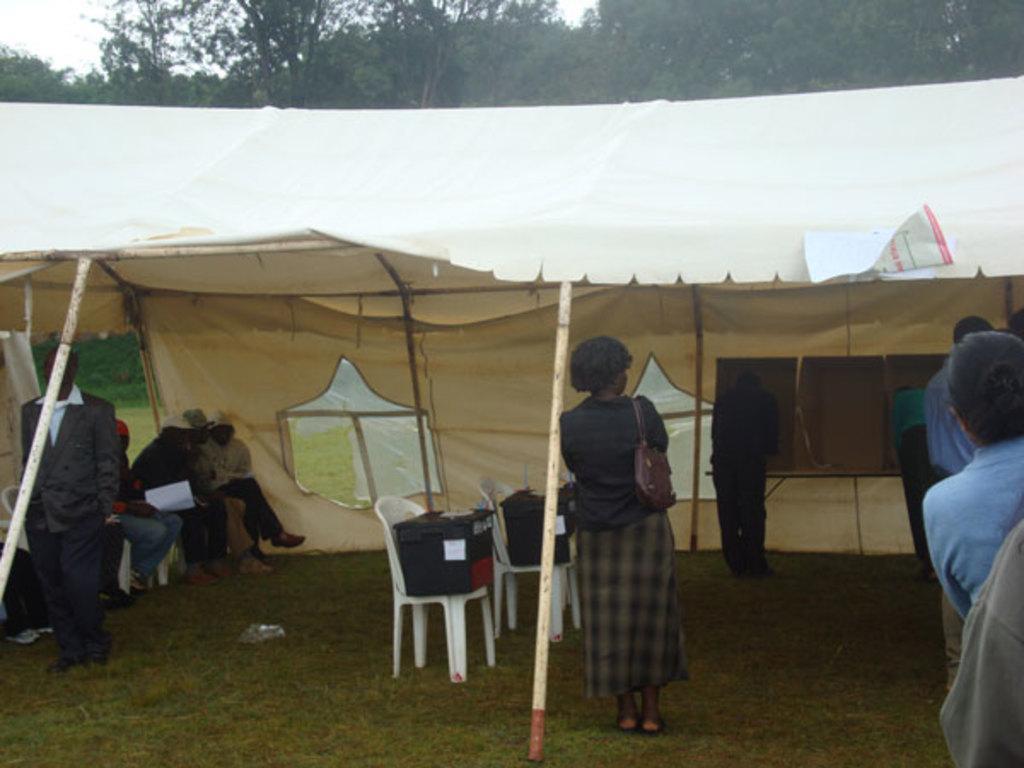In one or two sentences, can you explain what this image depicts? people are standing. there is a cream tent. there are white chairs in the tent on which there are boxes. at the left people are sitting and holding paper in their hand. behind that there are trees. 